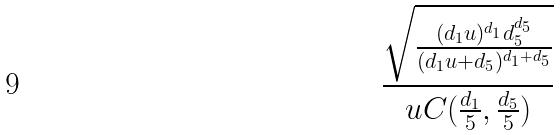Convert formula to latex. <formula><loc_0><loc_0><loc_500><loc_500>\frac { \sqrt { \frac { ( d _ { 1 } u ) ^ { d _ { 1 } } d _ { 5 } ^ { d _ { 5 } } } { ( d _ { 1 } u + d _ { 5 } ) ^ { d _ { 1 } + d _ { 5 } } } } } { u C ( \frac { d _ { 1 } } { 5 } , \frac { d _ { 5 } } { 5 } ) }</formula> 